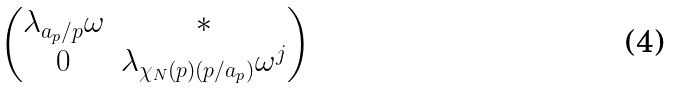Convert formula to latex. <formula><loc_0><loc_0><loc_500><loc_500>\begin{pmatrix} \lambda _ { a _ { p } / p } \omega & * \\ 0 & \lambda _ { \chi _ { N } ( p ) ( p / a _ { p } ) } \omega ^ { j } \end{pmatrix}</formula> 